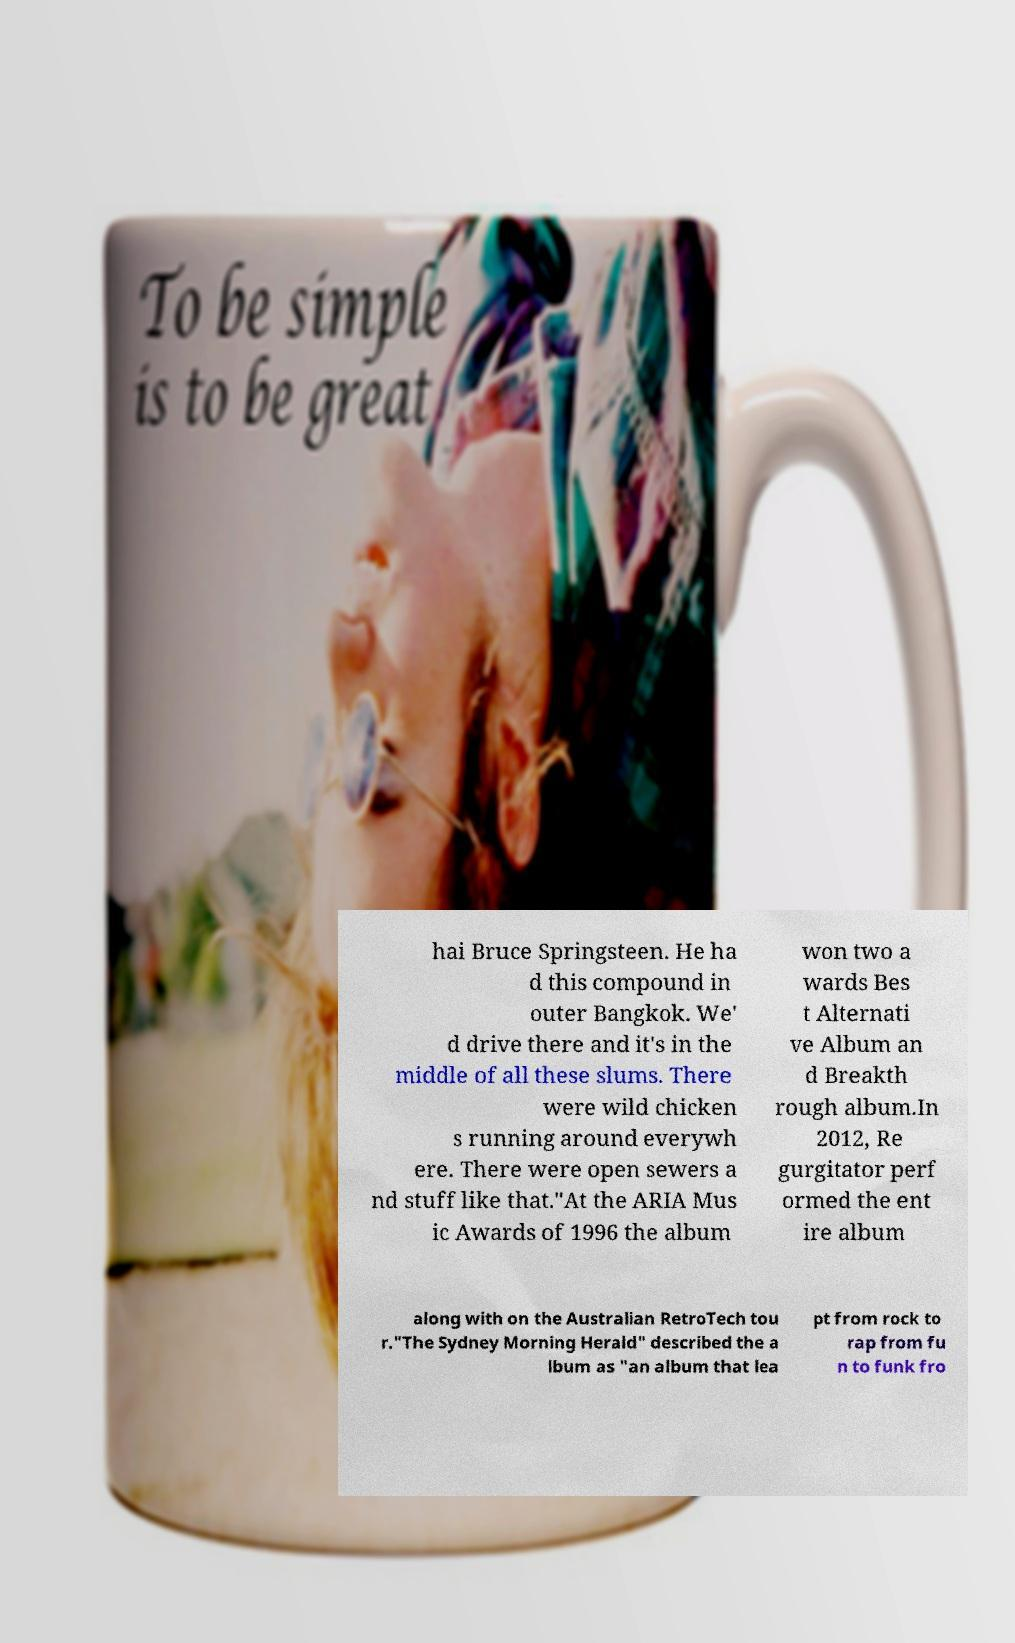I need the written content from this picture converted into text. Can you do that? hai Bruce Springsteen. He ha d this compound in outer Bangkok. We' d drive there and it's in the middle of all these slums. There were wild chicken s running around everywh ere. There were open sewers a nd stuff like that."At the ARIA Mus ic Awards of 1996 the album won two a wards Bes t Alternati ve Album an d Breakth rough album.In 2012, Re gurgitator perf ormed the ent ire album along with on the Australian RetroTech tou r."The Sydney Morning Herald" described the a lbum as "an album that lea pt from rock to rap from fu n to funk fro 